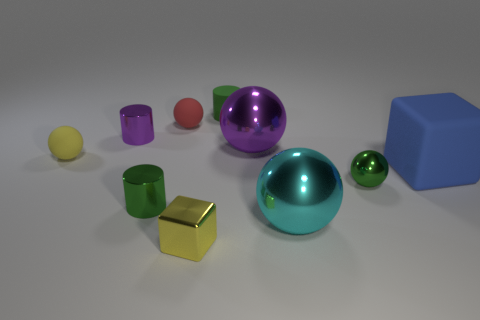What color is the matte cylinder? The matte cylinder in the image appears to be a shade of purple, more specifically, a lilac or lavender. It's standing upright between a reflective purple sphere and a smaller green glossy sphere. 